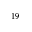Convert formula to latex. <formula><loc_0><loc_0><loc_500><loc_500>^ { 1 9 }</formula> 